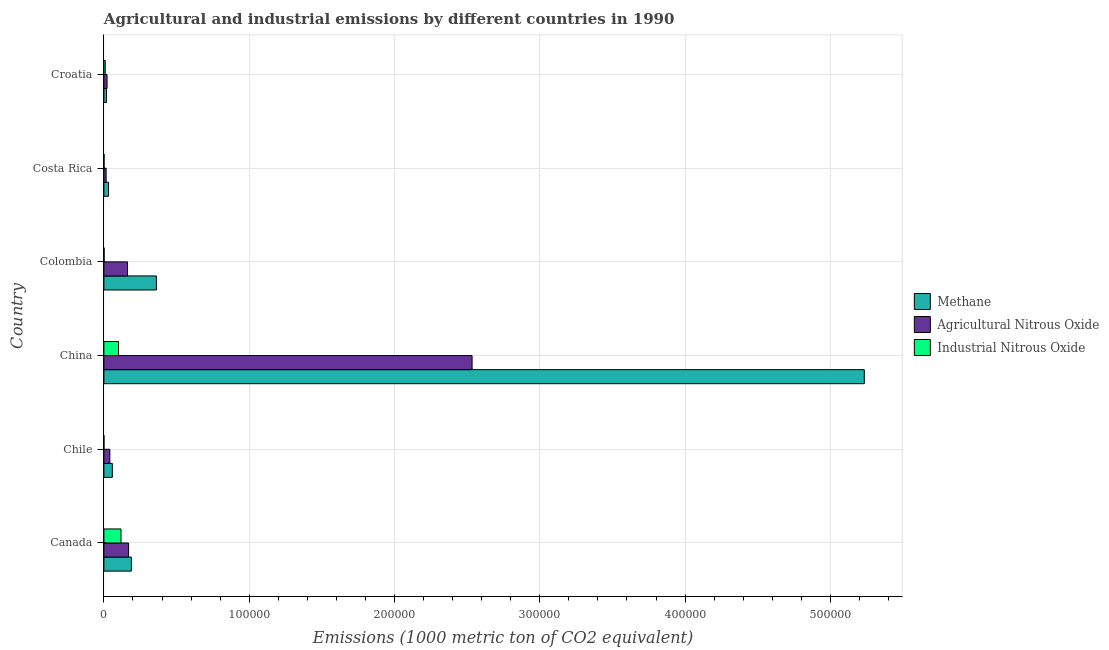How many bars are there on the 3rd tick from the top?
Offer a terse response. 3. How many bars are there on the 5th tick from the bottom?
Offer a very short reply. 3. What is the amount of methane emissions in Colombia?
Give a very brief answer. 3.61e+04. Across all countries, what is the maximum amount of methane emissions?
Provide a succinct answer. 5.23e+05. Across all countries, what is the minimum amount of agricultural nitrous oxide emissions?
Make the answer very short. 1535. In which country was the amount of methane emissions maximum?
Offer a terse response. China. In which country was the amount of methane emissions minimum?
Your answer should be very brief. Croatia. What is the total amount of industrial nitrous oxide emissions in the graph?
Provide a short and direct response. 2.31e+04. What is the difference between the amount of industrial nitrous oxide emissions in Canada and that in Chile?
Your answer should be very brief. 1.17e+04. What is the difference between the amount of industrial nitrous oxide emissions in Canada and the amount of agricultural nitrous oxide emissions in Chile?
Provide a succinct answer. 7673. What is the average amount of methane emissions per country?
Your response must be concise. 9.82e+04. What is the difference between the amount of methane emissions and amount of agricultural nitrous oxide emissions in Chile?
Offer a very short reply. 1708.8. In how many countries, is the amount of agricultural nitrous oxide emissions greater than 360000 metric ton?
Provide a succinct answer. 0. What is the ratio of the amount of methane emissions in Chile to that in Colombia?
Keep it short and to the point. 0.16. Is the amount of agricultural nitrous oxide emissions in Canada less than that in Costa Rica?
Offer a very short reply. No. Is the difference between the amount of agricultural nitrous oxide emissions in Chile and Croatia greater than the difference between the amount of methane emissions in Chile and Croatia?
Offer a terse response. No. What is the difference between the highest and the second highest amount of methane emissions?
Your answer should be very brief. 4.87e+05. What is the difference between the highest and the lowest amount of industrial nitrous oxide emissions?
Offer a terse response. 1.17e+04. What does the 3rd bar from the top in Canada represents?
Provide a short and direct response. Methane. What does the 1st bar from the bottom in Croatia represents?
Make the answer very short. Methane. Is it the case that in every country, the sum of the amount of methane emissions and amount of agricultural nitrous oxide emissions is greater than the amount of industrial nitrous oxide emissions?
Make the answer very short. Yes. How many bars are there?
Provide a succinct answer. 18. Are all the bars in the graph horizontal?
Make the answer very short. Yes. Are the values on the major ticks of X-axis written in scientific E-notation?
Your response must be concise. No. Where does the legend appear in the graph?
Make the answer very short. Center right. What is the title of the graph?
Your answer should be very brief. Agricultural and industrial emissions by different countries in 1990. What is the label or title of the X-axis?
Make the answer very short. Emissions (1000 metric ton of CO2 equivalent). What is the Emissions (1000 metric ton of CO2 equivalent) of Methane in Canada?
Give a very brief answer. 1.89e+04. What is the Emissions (1000 metric ton of CO2 equivalent) of Agricultural Nitrous Oxide in Canada?
Provide a short and direct response. 1.70e+04. What is the Emissions (1000 metric ton of CO2 equivalent) of Industrial Nitrous Oxide in Canada?
Provide a succinct answer. 1.18e+04. What is the Emissions (1000 metric ton of CO2 equivalent) in Methane in Chile?
Make the answer very short. 5805.8. What is the Emissions (1000 metric ton of CO2 equivalent) in Agricultural Nitrous Oxide in Chile?
Your answer should be compact. 4097. What is the Emissions (1000 metric ton of CO2 equivalent) in Industrial Nitrous Oxide in Chile?
Your answer should be very brief. 27.9. What is the Emissions (1000 metric ton of CO2 equivalent) of Methane in China?
Your response must be concise. 5.23e+05. What is the Emissions (1000 metric ton of CO2 equivalent) in Agricultural Nitrous Oxide in China?
Give a very brief answer. 2.53e+05. What is the Emissions (1000 metric ton of CO2 equivalent) of Industrial Nitrous Oxide in China?
Offer a very short reply. 1.01e+04. What is the Emissions (1000 metric ton of CO2 equivalent) of Methane in Colombia?
Provide a short and direct response. 3.61e+04. What is the Emissions (1000 metric ton of CO2 equivalent) in Agricultural Nitrous Oxide in Colombia?
Keep it short and to the point. 1.63e+04. What is the Emissions (1000 metric ton of CO2 equivalent) in Industrial Nitrous Oxide in Colombia?
Offer a very short reply. 171.6. What is the Emissions (1000 metric ton of CO2 equivalent) of Methane in Costa Rica?
Make the answer very short. 3204.6. What is the Emissions (1000 metric ton of CO2 equivalent) of Agricultural Nitrous Oxide in Costa Rica?
Keep it short and to the point. 1535. What is the Emissions (1000 metric ton of CO2 equivalent) in Industrial Nitrous Oxide in Costa Rica?
Give a very brief answer. 120. What is the Emissions (1000 metric ton of CO2 equivalent) of Methane in Croatia?
Offer a terse response. 1759.1. What is the Emissions (1000 metric ton of CO2 equivalent) in Agricultural Nitrous Oxide in Croatia?
Provide a short and direct response. 2179.7. What is the Emissions (1000 metric ton of CO2 equivalent) in Industrial Nitrous Oxide in Croatia?
Your response must be concise. 927.7. Across all countries, what is the maximum Emissions (1000 metric ton of CO2 equivalent) in Methane?
Make the answer very short. 5.23e+05. Across all countries, what is the maximum Emissions (1000 metric ton of CO2 equivalent) in Agricultural Nitrous Oxide?
Make the answer very short. 2.53e+05. Across all countries, what is the maximum Emissions (1000 metric ton of CO2 equivalent) of Industrial Nitrous Oxide?
Provide a succinct answer. 1.18e+04. Across all countries, what is the minimum Emissions (1000 metric ton of CO2 equivalent) of Methane?
Ensure brevity in your answer.  1759.1. Across all countries, what is the minimum Emissions (1000 metric ton of CO2 equivalent) in Agricultural Nitrous Oxide?
Make the answer very short. 1535. Across all countries, what is the minimum Emissions (1000 metric ton of CO2 equivalent) in Industrial Nitrous Oxide?
Offer a very short reply. 27.9. What is the total Emissions (1000 metric ton of CO2 equivalent) in Methane in the graph?
Provide a short and direct response. 5.89e+05. What is the total Emissions (1000 metric ton of CO2 equivalent) of Agricultural Nitrous Oxide in the graph?
Offer a very short reply. 2.94e+05. What is the total Emissions (1000 metric ton of CO2 equivalent) of Industrial Nitrous Oxide in the graph?
Your answer should be very brief. 2.31e+04. What is the difference between the Emissions (1000 metric ton of CO2 equivalent) in Methane in Canada and that in Chile?
Make the answer very short. 1.31e+04. What is the difference between the Emissions (1000 metric ton of CO2 equivalent) of Agricultural Nitrous Oxide in Canada and that in Chile?
Make the answer very short. 1.29e+04. What is the difference between the Emissions (1000 metric ton of CO2 equivalent) in Industrial Nitrous Oxide in Canada and that in Chile?
Make the answer very short. 1.17e+04. What is the difference between the Emissions (1000 metric ton of CO2 equivalent) of Methane in Canada and that in China?
Your answer should be very brief. -5.04e+05. What is the difference between the Emissions (1000 metric ton of CO2 equivalent) in Agricultural Nitrous Oxide in Canada and that in China?
Your answer should be very brief. -2.36e+05. What is the difference between the Emissions (1000 metric ton of CO2 equivalent) of Industrial Nitrous Oxide in Canada and that in China?
Your response must be concise. 1713.9. What is the difference between the Emissions (1000 metric ton of CO2 equivalent) in Methane in Canada and that in Colombia?
Provide a succinct answer. -1.72e+04. What is the difference between the Emissions (1000 metric ton of CO2 equivalent) in Agricultural Nitrous Oxide in Canada and that in Colombia?
Provide a short and direct response. 737.3. What is the difference between the Emissions (1000 metric ton of CO2 equivalent) of Industrial Nitrous Oxide in Canada and that in Colombia?
Give a very brief answer. 1.16e+04. What is the difference between the Emissions (1000 metric ton of CO2 equivalent) in Methane in Canada and that in Costa Rica?
Your answer should be compact. 1.57e+04. What is the difference between the Emissions (1000 metric ton of CO2 equivalent) in Agricultural Nitrous Oxide in Canada and that in Costa Rica?
Offer a very short reply. 1.55e+04. What is the difference between the Emissions (1000 metric ton of CO2 equivalent) in Industrial Nitrous Oxide in Canada and that in Costa Rica?
Ensure brevity in your answer.  1.16e+04. What is the difference between the Emissions (1000 metric ton of CO2 equivalent) of Methane in Canada and that in Croatia?
Keep it short and to the point. 1.72e+04. What is the difference between the Emissions (1000 metric ton of CO2 equivalent) of Agricultural Nitrous Oxide in Canada and that in Croatia?
Keep it short and to the point. 1.48e+04. What is the difference between the Emissions (1000 metric ton of CO2 equivalent) in Industrial Nitrous Oxide in Canada and that in Croatia?
Ensure brevity in your answer.  1.08e+04. What is the difference between the Emissions (1000 metric ton of CO2 equivalent) of Methane in Chile and that in China?
Provide a short and direct response. -5.18e+05. What is the difference between the Emissions (1000 metric ton of CO2 equivalent) in Agricultural Nitrous Oxide in Chile and that in China?
Your answer should be compact. -2.49e+05. What is the difference between the Emissions (1000 metric ton of CO2 equivalent) of Industrial Nitrous Oxide in Chile and that in China?
Offer a terse response. -1.00e+04. What is the difference between the Emissions (1000 metric ton of CO2 equivalent) in Methane in Chile and that in Colombia?
Ensure brevity in your answer.  -3.03e+04. What is the difference between the Emissions (1000 metric ton of CO2 equivalent) in Agricultural Nitrous Oxide in Chile and that in Colombia?
Give a very brief answer. -1.22e+04. What is the difference between the Emissions (1000 metric ton of CO2 equivalent) of Industrial Nitrous Oxide in Chile and that in Colombia?
Provide a short and direct response. -143.7. What is the difference between the Emissions (1000 metric ton of CO2 equivalent) of Methane in Chile and that in Costa Rica?
Your answer should be very brief. 2601.2. What is the difference between the Emissions (1000 metric ton of CO2 equivalent) of Agricultural Nitrous Oxide in Chile and that in Costa Rica?
Give a very brief answer. 2562. What is the difference between the Emissions (1000 metric ton of CO2 equivalent) of Industrial Nitrous Oxide in Chile and that in Costa Rica?
Offer a terse response. -92.1. What is the difference between the Emissions (1000 metric ton of CO2 equivalent) of Methane in Chile and that in Croatia?
Your answer should be very brief. 4046.7. What is the difference between the Emissions (1000 metric ton of CO2 equivalent) of Agricultural Nitrous Oxide in Chile and that in Croatia?
Your answer should be very brief. 1917.3. What is the difference between the Emissions (1000 metric ton of CO2 equivalent) of Industrial Nitrous Oxide in Chile and that in Croatia?
Your answer should be very brief. -899.8. What is the difference between the Emissions (1000 metric ton of CO2 equivalent) of Methane in China and that in Colombia?
Offer a very short reply. 4.87e+05. What is the difference between the Emissions (1000 metric ton of CO2 equivalent) of Agricultural Nitrous Oxide in China and that in Colombia?
Provide a succinct answer. 2.37e+05. What is the difference between the Emissions (1000 metric ton of CO2 equivalent) in Industrial Nitrous Oxide in China and that in Colombia?
Your response must be concise. 9884.5. What is the difference between the Emissions (1000 metric ton of CO2 equivalent) in Methane in China and that in Costa Rica?
Offer a very short reply. 5.20e+05. What is the difference between the Emissions (1000 metric ton of CO2 equivalent) in Agricultural Nitrous Oxide in China and that in Costa Rica?
Provide a short and direct response. 2.52e+05. What is the difference between the Emissions (1000 metric ton of CO2 equivalent) of Industrial Nitrous Oxide in China and that in Costa Rica?
Provide a short and direct response. 9936.1. What is the difference between the Emissions (1000 metric ton of CO2 equivalent) of Methane in China and that in Croatia?
Offer a very short reply. 5.22e+05. What is the difference between the Emissions (1000 metric ton of CO2 equivalent) in Agricultural Nitrous Oxide in China and that in Croatia?
Ensure brevity in your answer.  2.51e+05. What is the difference between the Emissions (1000 metric ton of CO2 equivalent) in Industrial Nitrous Oxide in China and that in Croatia?
Offer a very short reply. 9128.4. What is the difference between the Emissions (1000 metric ton of CO2 equivalent) in Methane in Colombia and that in Costa Rica?
Make the answer very short. 3.29e+04. What is the difference between the Emissions (1000 metric ton of CO2 equivalent) of Agricultural Nitrous Oxide in Colombia and that in Costa Rica?
Your answer should be very brief. 1.47e+04. What is the difference between the Emissions (1000 metric ton of CO2 equivalent) of Industrial Nitrous Oxide in Colombia and that in Costa Rica?
Provide a short and direct response. 51.6. What is the difference between the Emissions (1000 metric ton of CO2 equivalent) of Methane in Colombia and that in Croatia?
Offer a very short reply. 3.44e+04. What is the difference between the Emissions (1000 metric ton of CO2 equivalent) in Agricultural Nitrous Oxide in Colombia and that in Croatia?
Your answer should be very brief. 1.41e+04. What is the difference between the Emissions (1000 metric ton of CO2 equivalent) of Industrial Nitrous Oxide in Colombia and that in Croatia?
Your response must be concise. -756.1. What is the difference between the Emissions (1000 metric ton of CO2 equivalent) of Methane in Costa Rica and that in Croatia?
Your response must be concise. 1445.5. What is the difference between the Emissions (1000 metric ton of CO2 equivalent) of Agricultural Nitrous Oxide in Costa Rica and that in Croatia?
Offer a very short reply. -644.7. What is the difference between the Emissions (1000 metric ton of CO2 equivalent) in Industrial Nitrous Oxide in Costa Rica and that in Croatia?
Offer a terse response. -807.7. What is the difference between the Emissions (1000 metric ton of CO2 equivalent) of Methane in Canada and the Emissions (1000 metric ton of CO2 equivalent) of Agricultural Nitrous Oxide in Chile?
Make the answer very short. 1.48e+04. What is the difference between the Emissions (1000 metric ton of CO2 equivalent) in Methane in Canada and the Emissions (1000 metric ton of CO2 equivalent) in Industrial Nitrous Oxide in Chile?
Provide a succinct answer. 1.89e+04. What is the difference between the Emissions (1000 metric ton of CO2 equivalent) in Agricultural Nitrous Oxide in Canada and the Emissions (1000 metric ton of CO2 equivalent) in Industrial Nitrous Oxide in Chile?
Offer a very short reply. 1.70e+04. What is the difference between the Emissions (1000 metric ton of CO2 equivalent) in Methane in Canada and the Emissions (1000 metric ton of CO2 equivalent) in Agricultural Nitrous Oxide in China?
Keep it short and to the point. -2.34e+05. What is the difference between the Emissions (1000 metric ton of CO2 equivalent) of Methane in Canada and the Emissions (1000 metric ton of CO2 equivalent) of Industrial Nitrous Oxide in China?
Give a very brief answer. 8867.4. What is the difference between the Emissions (1000 metric ton of CO2 equivalent) in Agricultural Nitrous Oxide in Canada and the Emissions (1000 metric ton of CO2 equivalent) in Industrial Nitrous Oxide in China?
Give a very brief answer. 6943.3. What is the difference between the Emissions (1000 metric ton of CO2 equivalent) in Methane in Canada and the Emissions (1000 metric ton of CO2 equivalent) in Agricultural Nitrous Oxide in Colombia?
Offer a terse response. 2661.4. What is the difference between the Emissions (1000 metric ton of CO2 equivalent) of Methane in Canada and the Emissions (1000 metric ton of CO2 equivalent) of Industrial Nitrous Oxide in Colombia?
Your response must be concise. 1.88e+04. What is the difference between the Emissions (1000 metric ton of CO2 equivalent) of Agricultural Nitrous Oxide in Canada and the Emissions (1000 metric ton of CO2 equivalent) of Industrial Nitrous Oxide in Colombia?
Provide a short and direct response. 1.68e+04. What is the difference between the Emissions (1000 metric ton of CO2 equivalent) in Methane in Canada and the Emissions (1000 metric ton of CO2 equivalent) in Agricultural Nitrous Oxide in Costa Rica?
Provide a succinct answer. 1.74e+04. What is the difference between the Emissions (1000 metric ton of CO2 equivalent) of Methane in Canada and the Emissions (1000 metric ton of CO2 equivalent) of Industrial Nitrous Oxide in Costa Rica?
Offer a very short reply. 1.88e+04. What is the difference between the Emissions (1000 metric ton of CO2 equivalent) in Agricultural Nitrous Oxide in Canada and the Emissions (1000 metric ton of CO2 equivalent) in Industrial Nitrous Oxide in Costa Rica?
Ensure brevity in your answer.  1.69e+04. What is the difference between the Emissions (1000 metric ton of CO2 equivalent) of Methane in Canada and the Emissions (1000 metric ton of CO2 equivalent) of Agricultural Nitrous Oxide in Croatia?
Offer a terse response. 1.67e+04. What is the difference between the Emissions (1000 metric ton of CO2 equivalent) in Methane in Canada and the Emissions (1000 metric ton of CO2 equivalent) in Industrial Nitrous Oxide in Croatia?
Offer a very short reply. 1.80e+04. What is the difference between the Emissions (1000 metric ton of CO2 equivalent) of Agricultural Nitrous Oxide in Canada and the Emissions (1000 metric ton of CO2 equivalent) of Industrial Nitrous Oxide in Croatia?
Offer a very short reply. 1.61e+04. What is the difference between the Emissions (1000 metric ton of CO2 equivalent) of Methane in Chile and the Emissions (1000 metric ton of CO2 equivalent) of Agricultural Nitrous Oxide in China?
Provide a succinct answer. -2.48e+05. What is the difference between the Emissions (1000 metric ton of CO2 equivalent) of Methane in Chile and the Emissions (1000 metric ton of CO2 equivalent) of Industrial Nitrous Oxide in China?
Your response must be concise. -4250.3. What is the difference between the Emissions (1000 metric ton of CO2 equivalent) of Agricultural Nitrous Oxide in Chile and the Emissions (1000 metric ton of CO2 equivalent) of Industrial Nitrous Oxide in China?
Make the answer very short. -5959.1. What is the difference between the Emissions (1000 metric ton of CO2 equivalent) in Methane in Chile and the Emissions (1000 metric ton of CO2 equivalent) in Agricultural Nitrous Oxide in Colombia?
Ensure brevity in your answer.  -1.05e+04. What is the difference between the Emissions (1000 metric ton of CO2 equivalent) of Methane in Chile and the Emissions (1000 metric ton of CO2 equivalent) of Industrial Nitrous Oxide in Colombia?
Your answer should be compact. 5634.2. What is the difference between the Emissions (1000 metric ton of CO2 equivalent) in Agricultural Nitrous Oxide in Chile and the Emissions (1000 metric ton of CO2 equivalent) in Industrial Nitrous Oxide in Colombia?
Your answer should be very brief. 3925.4. What is the difference between the Emissions (1000 metric ton of CO2 equivalent) in Methane in Chile and the Emissions (1000 metric ton of CO2 equivalent) in Agricultural Nitrous Oxide in Costa Rica?
Your answer should be compact. 4270.8. What is the difference between the Emissions (1000 metric ton of CO2 equivalent) of Methane in Chile and the Emissions (1000 metric ton of CO2 equivalent) of Industrial Nitrous Oxide in Costa Rica?
Your answer should be very brief. 5685.8. What is the difference between the Emissions (1000 metric ton of CO2 equivalent) in Agricultural Nitrous Oxide in Chile and the Emissions (1000 metric ton of CO2 equivalent) in Industrial Nitrous Oxide in Costa Rica?
Make the answer very short. 3977. What is the difference between the Emissions (1000 metric ton of CO2 equivalent) of Methane in Chile and the Emissions (1000 metric ton of CO2 equivalent) of Agricultural Nitrous Oxide in Croatia?
Provide a short and direct response. 3626.1. What is the difference between the Emissions (1000 metric ton of CO2 equivalent) of Methane in Chile and the Emissions (1000 metric ton of CO2 equivalent) of Industrial Nitrous Oxide in Croatia?
Ensure brevity in your answer.  4878.1. What is the difference between the Emissions (1000 metric ton of CO2 equivalent) of Agricultural Nitrous Oxide in Chile and the Emissions (1000 metric ton of CO2 equivalent) of Industrial Nitrous Oxide in Croatia?
Your answer should be compact. 3169.3. What is the difference between the Emissions (1000 metric ton of CO2 equivalent) of Methane in China and the Emissions (1000 metric ton of CO2 equivalent) of Agricultural Nitrous Oxide in Colombia?
Your answer should be compact. 5.07e+05. What is the difference between the Emissions (1000 metric ton of CO2 equivalent) in Methane in China and the Emissions (1000 metric ton of CO2 equivalent) in Industrial Nitrous Oxide in Colombia?
Provide a succinct answer. 5.23e+05. What is the difference between the Emissions (1000 metric ton of CO2 equivalent) of Agricultural Nitrous Oxide in China and the Emissions (1000 metric ton of CO2 equivalent) of Industrial Nitrous Oxide in Colombia?
Offer a terse response. 2.53e+05. What is the difference between the Emissions (1000 metric ton of CO2 equivalent) of Methane in China and the Emissions (1000 metric ton of CO2 equivalent) of Agricultural Nitrous Oxide in Costa Rica?
Offer a terse response. 5.22e+05. What is the difference between the Emissions (1000 metric ton of CO2 equivalent) in Methane in China and the Emissions (1000 metric ton of CO2 equivalent) in Industrial Nitrous Oxide in Costa Rica?
Your response must be concise. 5.23e+05. What is the difference between the Emissions (1000 metric ton of CO2 equivalent) of Agricultural Nitrous Oxide in China and the Emissions (1000 metric ton of CO2 equivalent) of Industrial Nitrous Oxide in Costa Rica?
Offer a terse response. 2.53e+05. What is the difference between the Emissions (1000 metric ton of CO2 equivalent) of Methane in China and the Emissions (1000 metric ton of CO2 equivalent) of Agricultural Nitrous Oxide in Croatia?
Your answer should be very brief. 5.21e+05. What is the difference between the Emissions (1000 metric ton of CO2 equivalent) in Methane in China and the Emissions (1000 metric ton of CO2 equivalent) in Industrial Nitrous Oxide in Croatia?
Your response must be concise. 5.22e+05. What is the difference between the Emissions (1000 metric ton of CO2 equivalent) of Agricultural Nitrous Oxide in China and the Emissions (1000 metric ton of CO2 equivalent) of Industrial Nitrous Oxide in Croatia?
Your answer should be very brief. 2.52e+05. What is the difference between the Emissions (1000 metric ton of CO2 equivalent) in Methane in Colombia and the Emissions (1000 metric ton of CO2 equivalent) in Agricultural Nitrous Oxide in Costa Rica?
Make the answer very short. 3.46e+04. What is the difference between the Emissions (1000 metric ton of CO2 equivalent) in Methane in Colombia and the Emissions (1000 metric ton of CO2 equivalent) in Industrial Nitrous Oxide in Costa Rica?
Your response must be concise. 3.60e+04. What is the difference between the Emissions (1000 metric ton of CO2 equivalent) in Agricultural Nitrous Oxide in Colombia and the Emissions (1000 metric ton of CO2 equivalent) in Industrial Nitrous Oxide in Costa Rica?
Your response must be concise. 1.61e+04. What is the difference between the Emissions (1000 metric ton of CO2 equivalent) in Methane in Colombia and the Emissions (1000 metric ton of CO2 equivalent) in Agricultural Nitrous Oxide in Croatia?
Provide a short and direct response. 3.39e+04. What is the difference between the Emissions (1000 metric ton of CO2 equivalent) of Methane in Colombia and the Emissions (1000 metric ton of CO2 equivalent) of Industrial Nitrous Oxide in Croatia?
Your response must be concise. 3.52e+04. What is the difference between the Emissions (1000 metric ton of CO2 equivalent) in Agricultural Nitrous Oxide in Colombia and the Emissions (1000 metric ton of CO2 equivalent) in Industrial Nitrous Oxide in Croatia?
Ensure brevity in your answer.  1.53e+04. What is the difference between the Emissions (1000 metric ton of CO2 equivalent) of Methane in Costa Rica and the Emissions (1000 metric ton of CO2 equivalent) of Agricultural Nitrous Oxide in Croatia?
Your answer should be very brief. 1024.9. What is the difference between the Emissions (1000 metric ton of CO2 equivalent) in Methane in Costa Rica and the Emissions (1000 metric ton of CO2 equivalent) in Industrial Nitrous Oxide in Croatia?
Make the answer very short. 2276.9. What is the difference between the Emissions (1000 metric ton of CO2 equivalent) of Agricultural Nitrous Oxide in Costa Rica and the Emissions (1000 metric ton of CO2 equivalent) of Industrial Nitrous Oxide in Croatia?
Ensure brevity in your answer.  607.3. What is the average Emissions (1000 metric ton of CO2 equivalent) in Methane per country?
Offer a very short reply. 9.82e+04. What is the average Emissions (1000 metric ton of CO2 equivalent) in Agricultural Nitrous Oxide per country?
Provide a short and direct response. 4.91e+04. What is the average Emissions (1000 metric ton of CO2 equivalent) of Industrial Nitrous Oxide per country?
Ensure brevity in your answer.  3845.55. What is the difference between the Emissions (1000 metric ton of CO2 equivalent) of Methane and Emissions (1000 metric ton of CO2 equivalent) of Agricultural Nitrous Oxide in Canada?
Offer a very short reply. 1924.1. What is the difference between the Emissions (1000 metric ton of CO2 equivalent) of Methane and Emissions (1000 metric ton of CO2 equivalent) of Industrial Nitrous Oxide in Canada?
Your answer should be compact. 7153.5. What is the difference between the Emissions (1000 metric ton of CO2 equivalent) of Agricultural Nitrous Oxide and Emissions (1000 metric ton of CO2 equivalent) of Industrial Nitrous Oxide in Canada?
Offer a very short reply. 5229.4. What is the difference between the Emissions (1000 metric ton of CO2 equivalent) in Methane and Emissions (1000 metric ton of CO2 equivalent) in Agricultural Nitrous Oxide in Chile?
Offer a very short reply. 1708.8. What is the difference between the Emissions (1000 metric ton of CO2 equivalent) in Methane and Emissions (1000 metric ton of CO2 equivalent) in Industrial Nitrous Oxide in Chile?
Ensure brevity in your answer.  5777.9. What is the difference between the Emissions (1000 metric ton of CO2 equivalent) of Agricultural Nitrous Oxide and Emissions (1000 metric ton of CO2 equivalent) of Industrial Nitrous Oxide in Chile?
Provide a succinct answer. 4069.1. What is the difference between the Emissions (1000 metric ton of CO2 equivalent) in Methane and Emissions (1000 metric ton of CO2 equivalent) in Agricultural Nitrous Oxide in China?
Give a very brief answer. 2.70e+05. What is the difference between the Emissions (1000 metric ton of CO2 equivalent) of Methane and Emissions (1000 metric ton of CO2 equivalent) of Industrial Nitrous Oxide in China?
Offer a terse response. 5.13e+05. What is the difference between the Emissions (1000 metric ton of CO2 equivalent) of Agricultural Nitrous Oxide and Emissions (1000 metric ton of CO2 equivalent) of Industrial Nitrous Oxide in China?
Your response must be concise. 2.43e+05. What is the difference between the Emissions (1000 metric ton of CO2 equivalent) in Methane and Emissions (1000 metric ton of CO2 equivalent) in Agricultural Nitrous Oxide in Colombia?
Provide a succinct answer. 1.99e+04. What is the difference between the Emissions (1000 metric ton of CO2 equivalent) in Methane and Emissions (1000 metric ton of CO2 equivalent) in Industrial Nitrous Oxide in Colombia?
Give a very brief answer. 3.60e+04. What is the difference between the Emissions (1000 metric ton of CO2 equivalent) of Agricultural Nitrous Oxide and Emissions (1000 metric ton of CO2 equivalent) of Industrial Nitrous Oxide in Colombia?
Offer a very short reply. 1.61e+04. What is the difference between the Emissions (1000 metric ton of CO2 equivalent) in Methane and Emissions (1000 metric ton of CO2 equivalent) in Agricultural Nitrous Oxide in Costa Rica?
Provide a succinct answer. 1669.6. What is the difference between the Emissions (1000 metric ton of CO2 equivalent) of Methane and Emissions (1000 metric ton of CO2 equivalent) of Industrial Nitrous Oxide in Costa Rica?
Offer a terse response. 3084.6. What is the difference between the Emissions (1000 metric ton of CO2 equivalent) in Agricultural Nitrous Oxide and Emissions (1000 metric ton of CO2 equivalent) in Industrial Nitrous Oxide in Costa Rica?
Your response must be concise. 1415. What is the difference between the Emissions (1000 metric ton of CO2 equivalent) of Methane and Emissions (1000 metric ton of CO2 equivalent) of Agricultural Nitrous Oxide in Croatia?
Make the answer very short. -420.6. What is the difference between the Emissions (1000 metric ton of CO2 equivalent) of Methane and Emissions (1000 metric ton of CO2 equivalent) of Industrial Nitrous Oxide in Croatia?
Your answer should be compact. 831.4. What is the difference between the Emissions (1000 metric ton of CO2 equivalent) in Agricultural Nitrous Oxide and Emissions (1000 metric ton of CO2 equivalent) in Industrial Nitrous Oxide in Croatia?
Offer a terse response. 1252. What is the ratio of the Emissions (1000 metric ton of CO2 equivalent) in Methane in Canada to that in Chile?
Keep it short and to the point. 3.26. What is the ratio of the Emissions (1000 metric ton of CO2 equivalent) in Agricultural Nitrous Oxide in Canada to that in Chile?
Offer a very short reply. 4.15. What is the ratio of the Emissions (1000 metric ton of CO2 equivalent) in Industrial Nitrous Oxide in Canada to that in Chile?
Your answer should be compact. 421.86. What is the ratio of the Emissions (1000 metric ton of CO2 equivalent) of Methane in Canada to that in China?
Your answer should be compact. 0.04. What is the ratio of the Emissions (1000 metric ton of CO2 equivalent) of Agricultural Nitrous Oxide in Canada to that in China?
Provide a succinct answer. 0.07. What is the ratio of the Emissions (1000 metric ton of CO2 equivalent) in Industrial Nitrous Oxide in Canada to that in China?
Keep it short and to the point. 1.17. What is the ratio of the Emissions (1000 metric ton of CO2 equivalent) of Methane in Canada to that in Colombia?
Provide a succinct answer. 0.52. What is the ratio of the Emissions (1000 metric ton of CO2 equivalent) in Agricultural Nitrous Oxide in Canada to that in Colombia?
Offer a very short reply. 1.05. What is the ratio of the Emissions (1000 metric ton of CO2 equivalent) of Industrial Nitrous Oxide in Canada to that in Colombia?
Keep it short and to the point. 68.59. What is the ratio of the Emissions (1000 metric ton of CO2 equivalent) of Methane in Canada to that in Costa Rica?
Make the answer very short. 5.91. What is the ratio of the Emissions (1000 metric ton of CO2 equivalent) of Agricultural Nitrous Oxide in Canada to that in Costa Rica?
Your answer should be very brief. 11.07. What is the ratio of the Emissions (1000 metric ton of CO2 equivalent) of Industrial Nitrous Oxide in Canada to that in Costa Rica?
Keep it short and to the point. 98.08. What is the ratio of the Emissions (1000 metric ton of CO2 equivalent) of Methane in Canada to that in Croatia?
Ensure brevity in your answer.  10.76. What is the ratio of the Emissions (1000 metric ton of CO2 equivalent) in Agricultural Nitrous Oxide in Canada to that in Croatia?
Your answer should be compact. 7.8. What is the ratio of the Emissions (1000 metric ton of CO2 equivalent) in Industrial Nitrous Oxide in Canada to that in Croatia?
Your response must be concise. 12.69. What is the ratio of the Emissions (1000 metric ton of CO2 equivalent) in Methane in Chile to that in China?
Your answer should be very brief. 0.01. What is the ratio of the Emissions (1000 metric ton of CO2 equivalent) of Agricultural Nitrous Oxide in Chile to that in China?
Ensure brevity in your answer.  0.02. What is the ratio of the Emissions (1000 metric ton of CO2 equivalent) of Industrial Nitrous Oxide in Chile to that in China?
Offer a very short reply. 0. What is the ratio of the Emissions (1000 metric ton of CO2 equivalent) of Methane in Chile to that in Colombia?
Ensure brevity in your answer.  0.16. What is the ratio of the Emissions (1000 metric ton of CO2 equivalent) in Agricultural Nitrous Oxide in Chile to that in Colombia?
Ensure brevity in your answer.  0.25. What is the ratio of the Emissions (1000 metric ton of CO2 equivalent) of Industrial Nitrous Oxide in Chile to that in Colombia?
Your answer should be very brief. 0.16. What is the ratio of the Emissions (1000 metric ton of CO2 equivalent) of Methane in Chile to that in Costa Rica?
Your response must be concise. 1.81. What is the ratio of the Emissions (1000 metric ton of CO2 equivalent) in Agricultural Nitrous Oxide in Chile to that in Costa Rica?
Offer a terse response. 2.67. What is the ratio of the Emissions (1000 metric ton of CO2 equivalent) of Industrial Nitrous Oxide in Chile to that in Costa Rica?
Ensure brevity in your answer.  0.23. What is the ratio of the Emissions (1000 metric ton of CO2 equivalent) in Methane in Chile to that in Croatia?
Keep it short and to the point. 3.3. What is the ratio of the Emissions (1000 metric ton of CO2 equivalent) in Agricultural Nitrous Oxide in Chile to that in Croatia?
Make the answer very short. 1.88. What is the ratio of the Emissions (1000 metric ton of CO2 equivalent) in Industrial Nitrous Oxide in Chile to that in Croatia?
Give a very brief answer. 0.03. What is the ratio of the Emissions (1000 metric ton of CO2 equivalent) of Methane in China to that in Colombia?
Make the answer very short. 14.49. What is the ratio of the Emissions (1000 metric ton of CO2 equivalent) of Agricultural Nitrous Oxide in China to that in Colombia?
Your response must be concise. 15.58. What is the ratio of the Emissions (1000 metric ton of CO2 equivalent) in Industrial Nitrous Oxide in China to that in Colombia?
Make the answer very short. 58.6. What is the ratio of the Emissions (1000 metric ton of CO2 equivalent) of Methane in China to that in Costa Rica?
Offer a very short reply. 163.31. What is the ratio of the Emissions (1000 metric ton of CO2 equivalent) of Agricultural Nitrous Oxide in China to that in Costa Rica?
Offer a very short reply. 165.08. What is the ratio of the Emissions (1000 metric ton of CO2 equivalent) of Industrial Nitrous Oxide in China to that in Costa Rica?
Give a very brief answer. 83.8. What is the ratio of the Emissions (1000 metric ton of CO2 equivalent) in Methane in China to that in Croatia?
Keep it short and to the point. 297.5. What is the ratio of the Emissions (1000 metric ton of CO2 equivalent) in Agricultural Nitrous Oxide in China to that in Croatia?
Ensure brevity in your answer.  116.26. What is the ratio of the Emissions (1000 metric ton of CO2 equivalent) of Industrial Nitrous Oxide in China to that in Croatia?
Provide a succinct answer. 10.84. What is the ratio of the Emissions (1000 metric ton of CO2 equivalent) of Methane in Colombia to that in Costa Rica?
Your answer should be very brief. 11.27. What is the ratio of the Emissions (1000 metric ton of CO2 equivalent) in Agricultural Nitrous Oxide in Colombia to that in Costa Rica?
Provide a short and direct response. 10.59. What is the ratio of the Emissions (1000 metric ton of CO2 equivalent) in Industrial Nitrous Oxide in Colombia to that in Costa Rica?
Make the answer very short. 1.43. What is the ratio of the Emissions (1000 metric ton of CO2 equivalent) of Methane in Colombia to that in Croatia?
Your answer should be very brief. 20.54. What is the ratio of the Emissions (1000 metric ton of CO2 equivalent) of Agricultural Nitrous Oxide in Colombia to that in Croatia?
Make the answer very short. 7.46. What is the ratio of the Emissions (1000 metric ton of CO2 equivalent) of Industrial Nitrous Oxide in Colombia to that in Croatia?
Make the answer very short. 0.18. What is the ratio of the Emissions (1000 metric ton of CO2 equivalent) in Methane in Costa Rica to that in Croatia?
Offer a terse response. 1.82. What is the ratio of the Emissions (1000 metric ton of CO2 equivalent) of Agricultural Nitrous Oxide in Costa Rica to that in Croatia?
Ensure brevity in your answer.  0.7. What is the ratio of the Emissions (1000 metric ton of CO2 equivalent) in Industrial Nitrous Oxide in Costa Rica to that in Croatia?
Make the answer very short. 0.13. What is the difference between the highest and the second highest Emissions (1000 metric ton of CO2 equivalent) of Methane?
Offer a very short reply. 4.87e+05. What is the difference between the highest and the second highest Emissions (1000 metric ton of CO2 equivalent) of Agricultural Nitrous Oxide?
Give a very brief answer. 2.36e+05. What is the difference between the highest and the second highest Emissions (1000 metric ton of CO2 equivalent) of Industrial Nitrous Oxide?
Your answer should be compact. 1713.9. What is the difference between the highest and the lowest Emissions (1000 metric ton of CO2 equivalent) in Methane?
Your answer should be very brief. 5.22e+05. What is the difference between the highest and the lowest Emissions (1000 metric ton of CO2 equivalent) of Agricultural Nitrous Oxide?
Your answer should be very brief. 2.52e+05. What is the difference between the highest and the lowest Emissions (1000 metric ton of CO2 equivalent) of Industrial Nitrous Oxide?
Offer a very short reply. 1.17e+04. 